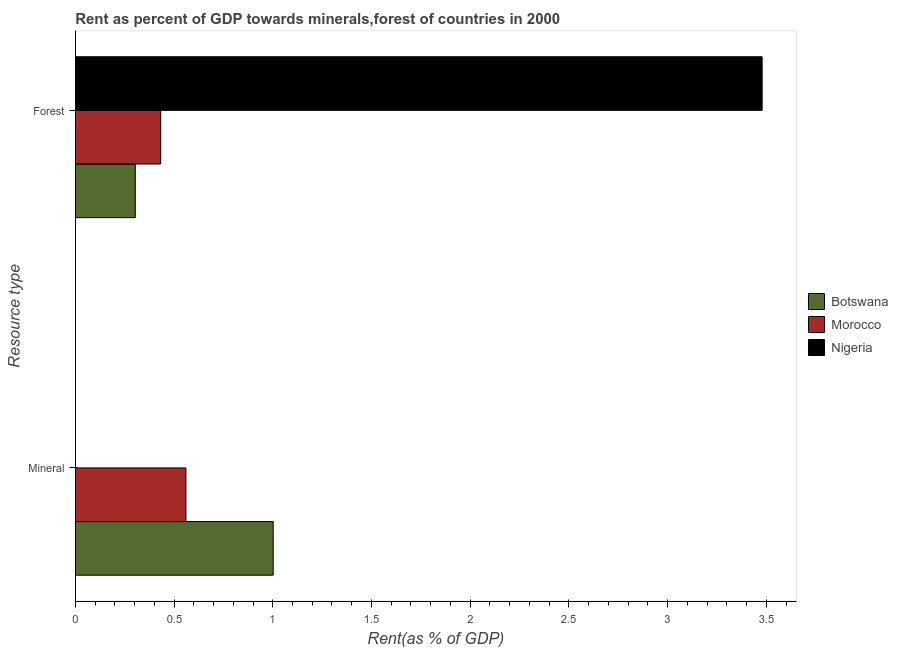How many different coloured bars are there?
Provide a short and direct response. 3. Are the number of bars on each tick of the Y-axis equal?
Offer a terse response. Yes. How many bars are there on the 1st tick from the bottom?
Your response must be concise. 3. What is the label of the 2nd group of bars from the top?
Provide a succinct answer. Mineral. What is the mineral rent in Nigeria?
Your answer should be very brief. 0. Across all countries, what is the maximum mineral rent?
Keep it short and to the point. 1. Across all countries, what is the minimum mineral rent?
Your answer should be compact. 0. In which country was the mineral rent maximum?
Your answer should be very brief. Botswana. In which country was the forest rent minimum?
Provide a succinct answer. Botswana. What is the total forest rent in the graph?
Make the answer very short. 4.22. What is the difference between the mineral rent in Morocco and that in Botswana?
Offer a terse response. -0.44. What is the difference between the mineral rent in Morocco and the forest rent in Nigeria?
Your answer should be very brief. -2.92. What is the average mineral rent per country?
Make the answer very short. 0.52. What is the difference between the mineral rent and forest rent in Nigeria?
Give a very brief answer. -3.48. What is the ratio of the forest rent in Botswana to that in Nigeria?
Offer a terse response. 0.09. What does the 3rd bar from the top in Forest represents?
Offer a terse response. Botswana. What does the 1st bar from the bottom in Mineral represents?
Provide a short and direct response. Botswana. Are the values on the major ticks of X-axis written in scientific E-notation?
Make the answer very short. No. How many legend labels are there?
Make the answer very short. 3. How are the legend labels stacked?
Offer a very short reply. Vertical. What is the title of the graph?
Your answer should be compact. Rent as percent of GDP towards minerals,forest of countries in 2000. Does "World" appear as one of the legend labels in the graph?
Keep it short and to the point. No. What is the label or title of the X-axis?
Keep it short and to the point. Rent(as % of GDP). What is the label or title of the Y-axis?
Give a very brief answer. Resource type. What is the Rent(as % of GDP) in Botswana in Mineral?
Make the answer very short. 1. What is the Rent(as % of GDP) of Morocco in Mineral?
Offer a terse response. 0.56. What is the Rent(as % of GDP) of Nigeria in Mineral?
Offer a terse response. 0. What is the Rent(as % of GDP) of Botswana in Forest?
Provide a short and direct response. 0.3. What is the Rent(as % of GDP) in Morocco in Forest?
Provide a succinct answer. 0.43. What is the Rent(as % of GDP) in Nigeria in Forest?
Offer a terse response. 3.48. Across all Resource type, what is the maximum Rent(as % of GDP) in Botswana?
Your answer should be compact. 1. Across all Resource type, what is the maximum Rent(as % of GDP) in Morocco?
Give a very brief answer. 0.56. Across all Resource type, what is the maximum Rent(as % of GDP) of Nigeria?
Make the answer very short. 3.48. Across all Resource type, what is the minimum Rent(as % of GDP) in Botswana?
Your answer should be very brief. 0.3. Across all Resource type, what is the minimum Rent(as % of GDP) in Morocco?
Offer a very short reply. 0.43. Across all Resource type, what is the minimum Rent(as % of GDP) in Nigeria?
Your answer should be compact. 0. What is the total Rent(as % of GDP) in Botswana in the graph?
Ensure brevity in your answer.  1.31. What is the total Rent(as % of GDP) of Nigeria in the graph?
Provide a short and direct response. 3.48. What is the difference between the Rent(as % of GDP) in Botswana in Mineral and that in Forest?
Make the answer very short. 0.7. What is the difference between the Rent(as % of GDP) of Morocco in Mineral and that in Forest?
Ensure brevity in your answer.  0.13. What is the difference between the Rent(as % of GDP) of Nigeria in Mineral and that in Forest?
Keep it short and to the point. -3.48. What is the difference between the Rent(as % of GDP) in Botswana in Mineral and the Rent(as % of GDP) in Morocco in Forest?
Your answer should be compact. 0.57. What is the difference between the Rent(as % of GDP) of Botswana in Mineral and the Rent(as % of GDP) of Nigeria in Forest?
Provide a short and direct response. -2.48. What is the difference between the Rent(as % of GDP) of Morocco in Mineral and the Rent(as % of GDP) of Nigeria in Forest?
Provide a short and direct response. -2.92. What is the average Rent(as % of GDP) in Botswana per Resource type?
Offer a very short reply. 0.65. What is the average Rent(as % of GDP) in Morocco per Resource type?
Provide a short and direct response. 0.5. What is the average Rent(as % of GDP) in Nigeria per Resource type?
Your answer should be compact. 1.74. What is the difference between the Rent(as % of GDP) of Botswana and Rent(as % of GDP) of Morocco in Mineral?
Keep it short and to the point. 0.44. What is the difference between the Rent(as % of GDP) in Morocco and Rent(as % of GDP) in Nigeria in Mineral?
Your answer should be very brief. 0.56. What is the difference between the Rent(as % of GDP) in Botswana and Rent(as % of GDP) in Morocco in Forest?
Make the answer very short. -0.13. What is the difference between the Rent(as % of GDP) in Botswana and Rent(as % of GDP) in Nigeria in Forest?
Offer a very short reply. -3.17. What is the difference between the Rent(as % of GDP) of Morocco and Rent(as % of GDP) of Nigeria in Forest?
Offer a very short reply. -3.05. What is the ratio of the Rent(as % of GDP) of Botswana in Mineral to that in Forest?
Your answer should be very brief. 3.3. What is the ratio of the Rent(as % of GDP) in Morocco in Mineral to that in Forest?
Your answer should be compact. 1.3. What is the difference between the highest and the second highest Rent(as % of GDP) of Botswana?
Ensure brevity in your answer.  0.7. What is the difference between the highest and the second highest Rent(as % of GDP) of Morocco?
Offer a very short reply. 0.13. What is the difference between the highest and the second highest Rent(as % of GDP) of Nigeria?
Offer a very short reply. 3.48. What is the difference between the highest and the lowest Rent(as % of GDP) in Botswana?
Offer a terse response. 0.7. What is the difference between the highest and the lowest Rent(as % of GDP) of Morocco?
Your response must be concise. 0.13. What is the difference between the highest and the lowest Rent(as % of GDP) in Nigeria?
Give a very brief answer. 3.48. 